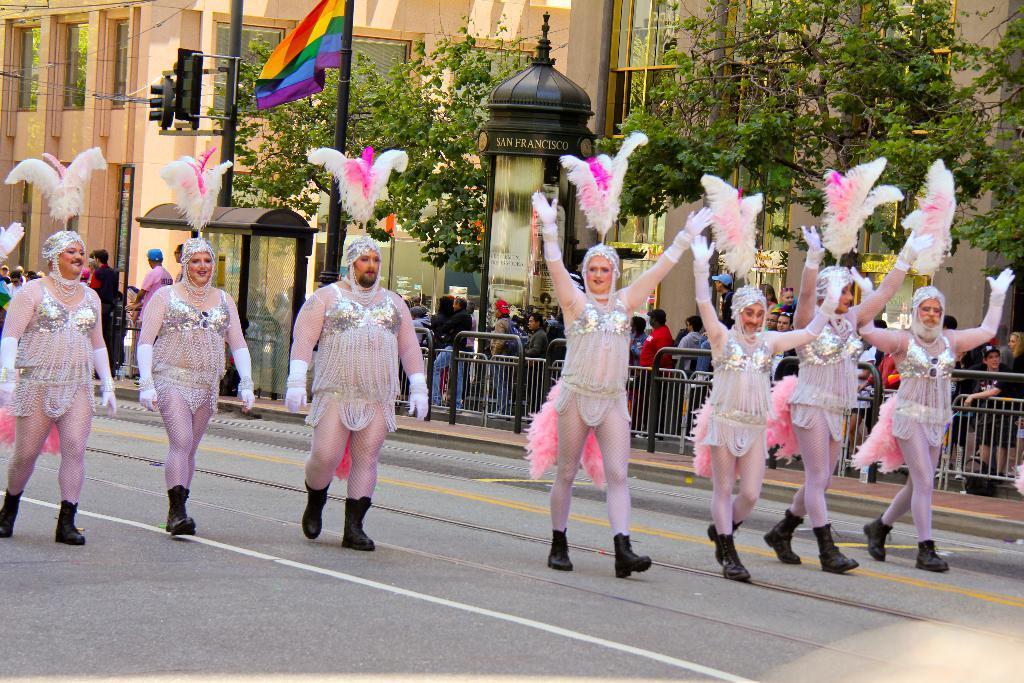Please provide a concise description of this image. In this image I can see a group of people are wearing costumes on the road. In the background I can see a fence, crowd, traffic lights, trees, windows and buildings. This image is taken during a sunny day. 